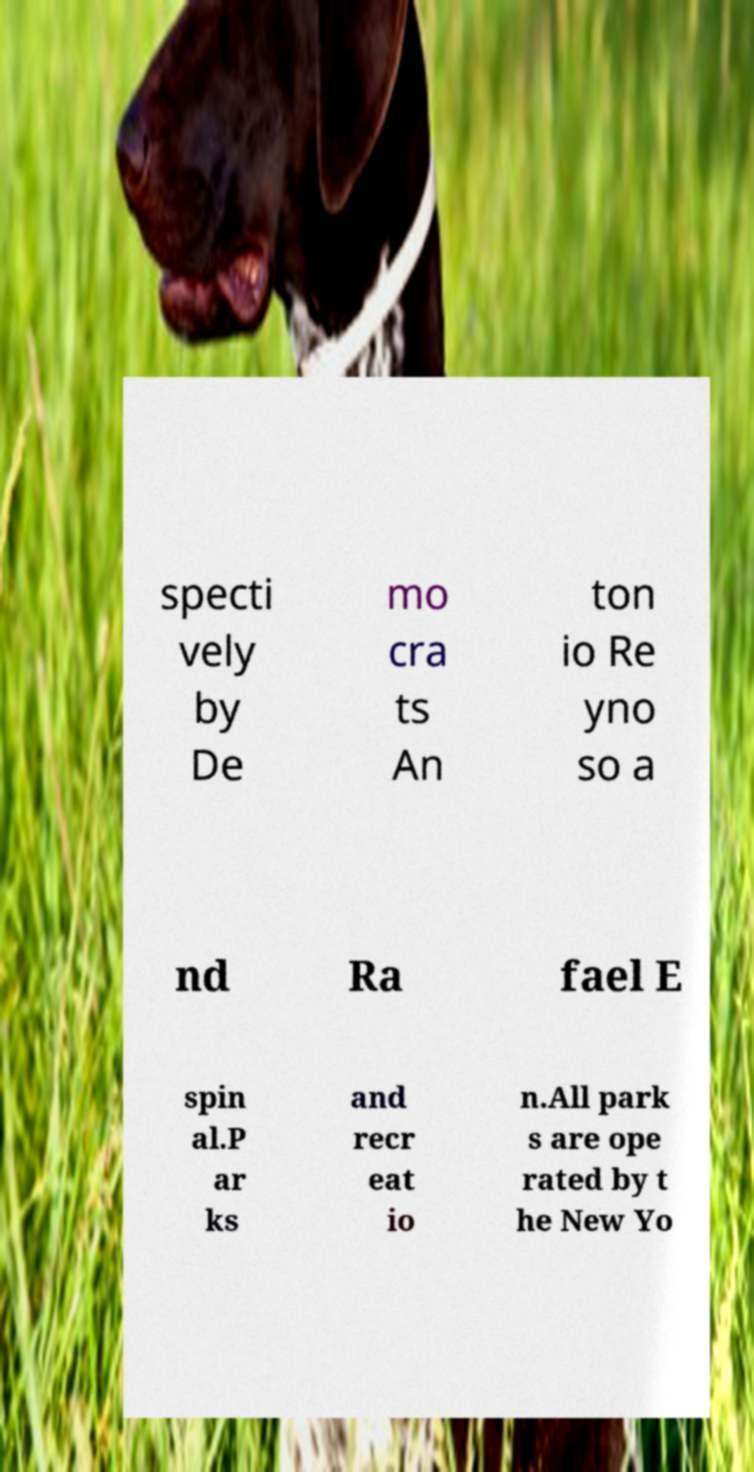I need the written content from this picture converted into text. Can you do that? specti vely by De mo cra ts An ton io Re yno so a nd Ra fael E spin al.P ar ks and recr eat io n.All park s are ope rated by t he New Yo 